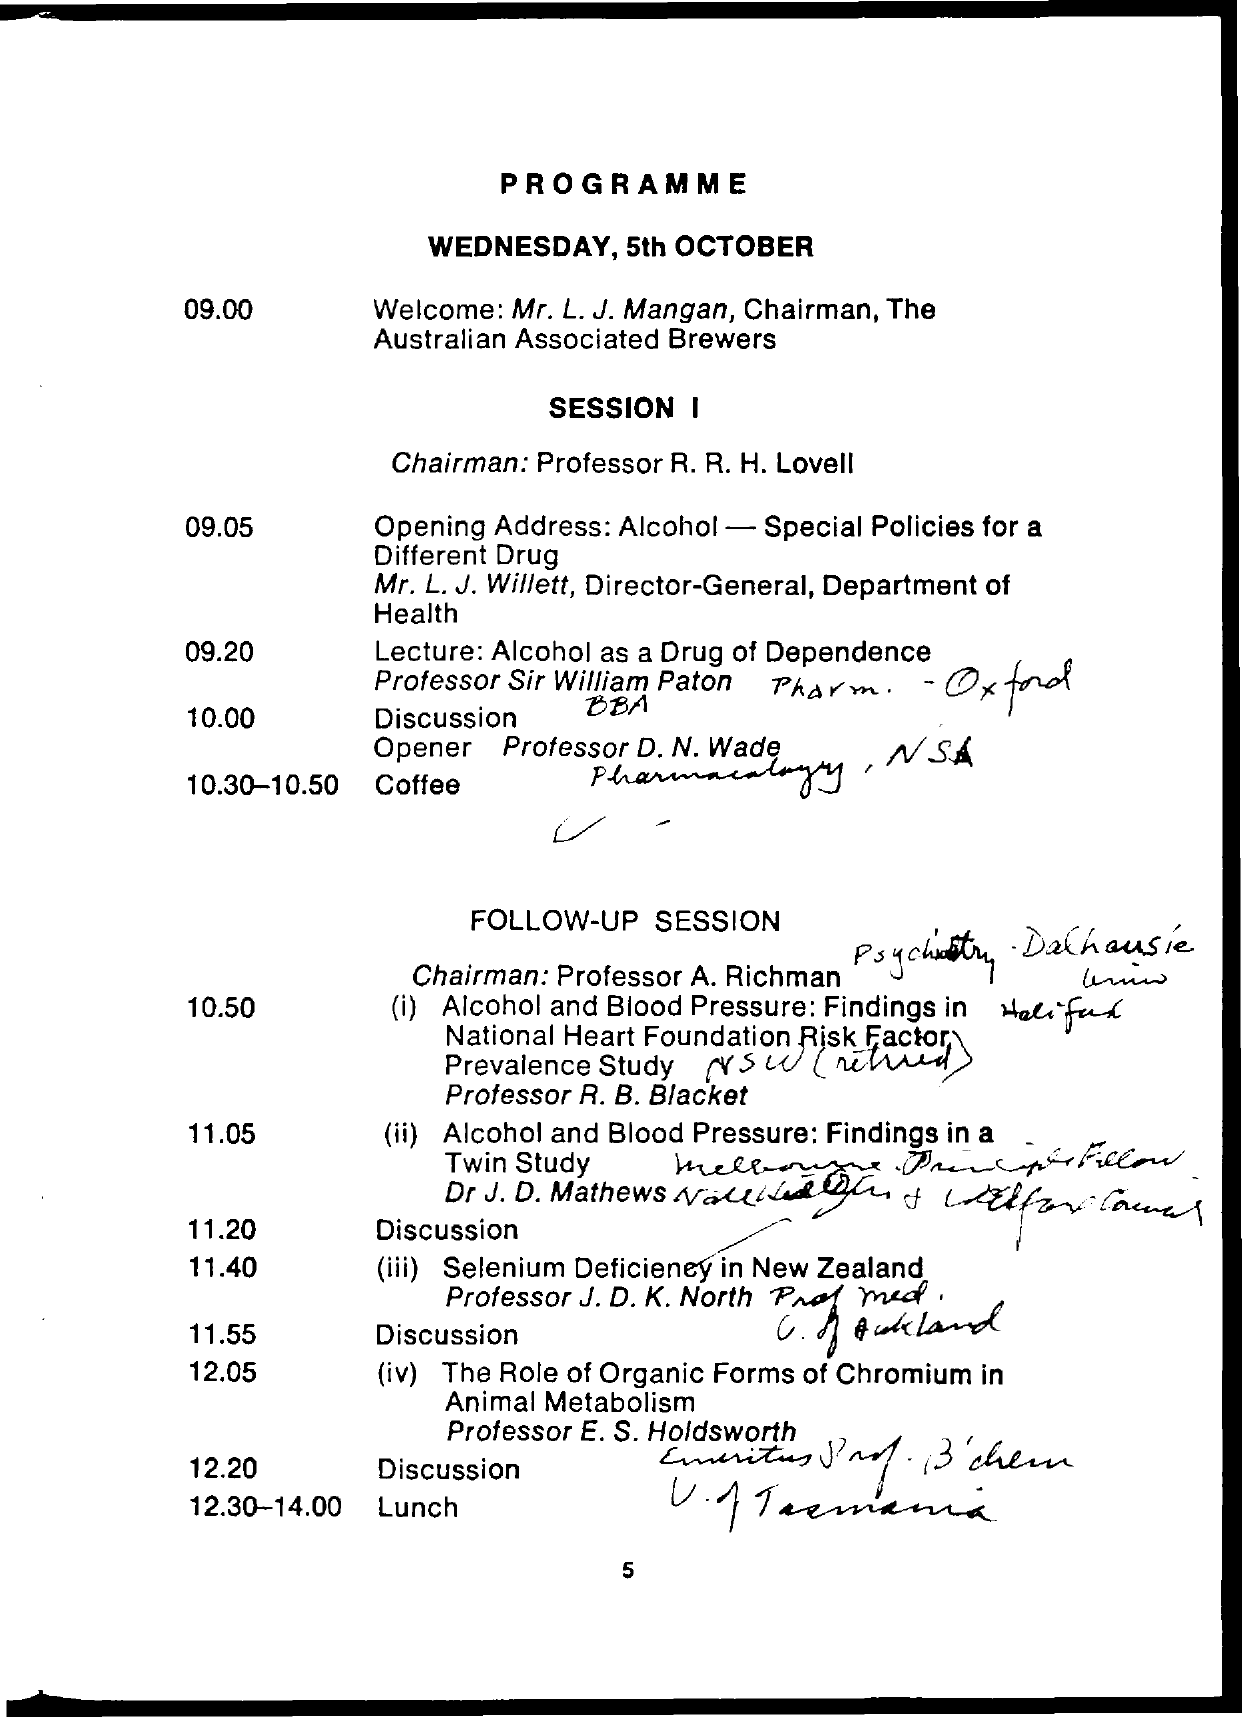What is the date mentioned ?
Provide a succinct answer. Wednesday , 5th october. When  is the lunch time ?
Your answer should be very brief. 12:30-14:00. When  is the coffee time
Offer a terse response. 10:30-10:50. 